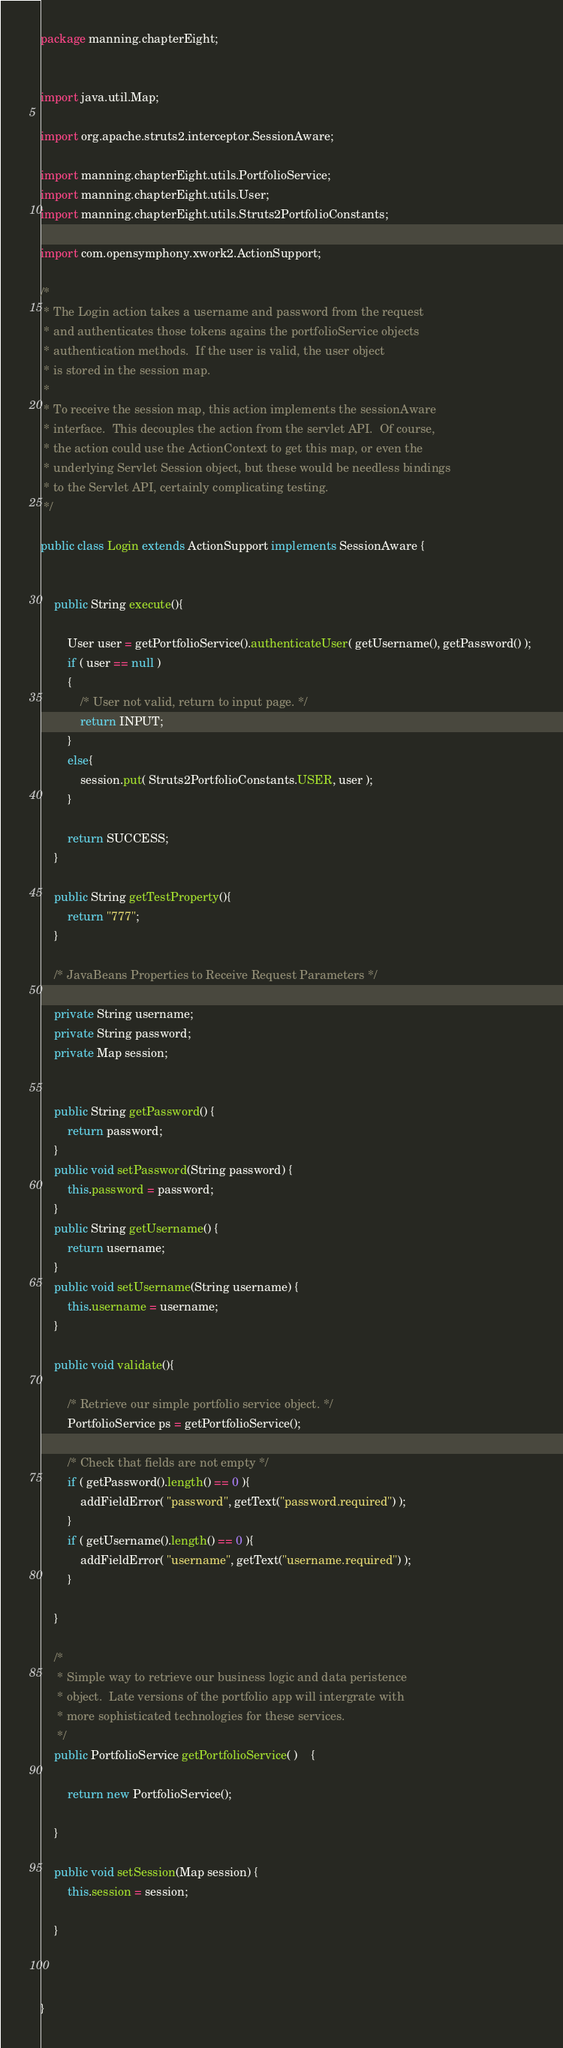Convert code to text. <code><loc_0><loc_0><loc_500><loc_500><_Java_>package manning.chapterEight;


import java.util.Map;

import org.apache.struts2.interceptor.SessionAware;

import manning.chapterEight.utils.PortfolioService;
import manning.chapterEight.utils.User;
import manning.chapterEight.utils.Struts2PortfolioConstants;

import com.opensymphony.xwork2.ActionSupport;

/*
 * The Login action takes a username and password from the request
 * and authenticates those tokens agains the portfolioService objects
 * authentication methods.  If the user is valid, the user object
 * is stored in the session map. 
 * 
 * To receive the session map, this action implements the sessionAware
 * interface.  This decouples the action from the servlet API.  Of course,
 * the action could use the ActionContext to get this map, or even the 
 * underlying Servlet Session object, but these would be needless bindings 
 * to the Servlet API, certainly complicating testing. 
 */

public class Login extends ActionSupport implements SessionAware {
	

	public String execute(){
		
		User user = getPortfolioService().authenticateUser( getUsername(), getPassword() ); 
		if ( user == null )
		{
			/* User not valid, return to input page. */
			return INPUT;
		}
		else{
			session.put( Struts2PortfolioConstants.USER, user );
		}
		
		return SUCCESS;
	}
	
	public String getTestProperty(){
		return "777";
	}
	
	/* JavaBeans Properties to Receive Request Parameters */
	
	private String username;
	private String password;
	private Map session;


	public String getPassword() {
		return password;
	}
	public void setPassword(String password) {
		this.password = password;
	}
	public String getUsername() {
		return username;
	}
	public void setUsername(String username) {
		this.username = username;
	}
	
	public void validate(){
		
		/* Retrieve our simple portfolio service object. */
		PortfolioService ps = getPortfolioService();
		
		/* Check that fields are not empty */
		if ( getPassword().length() == 0 ){			
			addFieldError( "password", getText("password.required") );
		}
		if ( getUsername().length() == 0 ){			
			addFieldError( "username", getText("username.required") );
		}

	}
	
	/*  
	 * Simple way to retrieve our business logic and data peristence
	 * object.  Late versions of the portfolio app will intergrate with
	 * more sophisticated technologies for these services.
	 */
	public PortfolioService getPortfolioService( ) 	{
		
		return new PortfolioService();
		
	}

	public void setSession(Map session) {
		this.session = session;
		
	}
	
	

}
</code> 